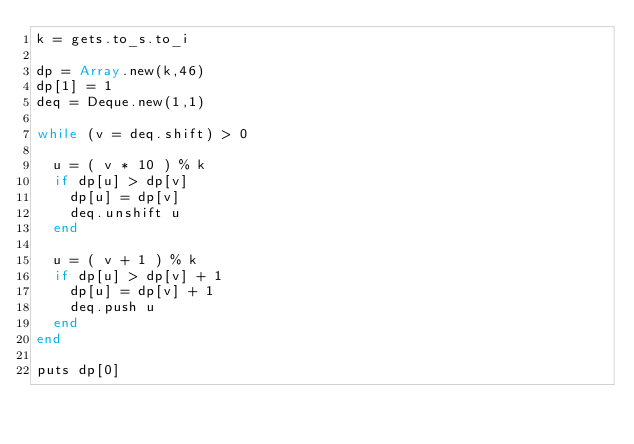<code> <loc_0><loc_0><loc_500><loc_500><_Crystal_>k = gets.to_s.to_i
 
dp = Array.new(k,46)
dp[1] = 1
deq = Deque.new(1,1)

while (v = deq.shift) > 0
  
  u = ( v * 10 ) % k
  if dp[u] > dp[v]
    dp[u] = dp[v]
    deq.unshift u
  end
  
  u = ( v + 1 ) % k
  if dp[u] > dp[v] + 1
    dp[u] = dp[v] + 1
    deq.push u
  end
end

puts dp[0]</code> 